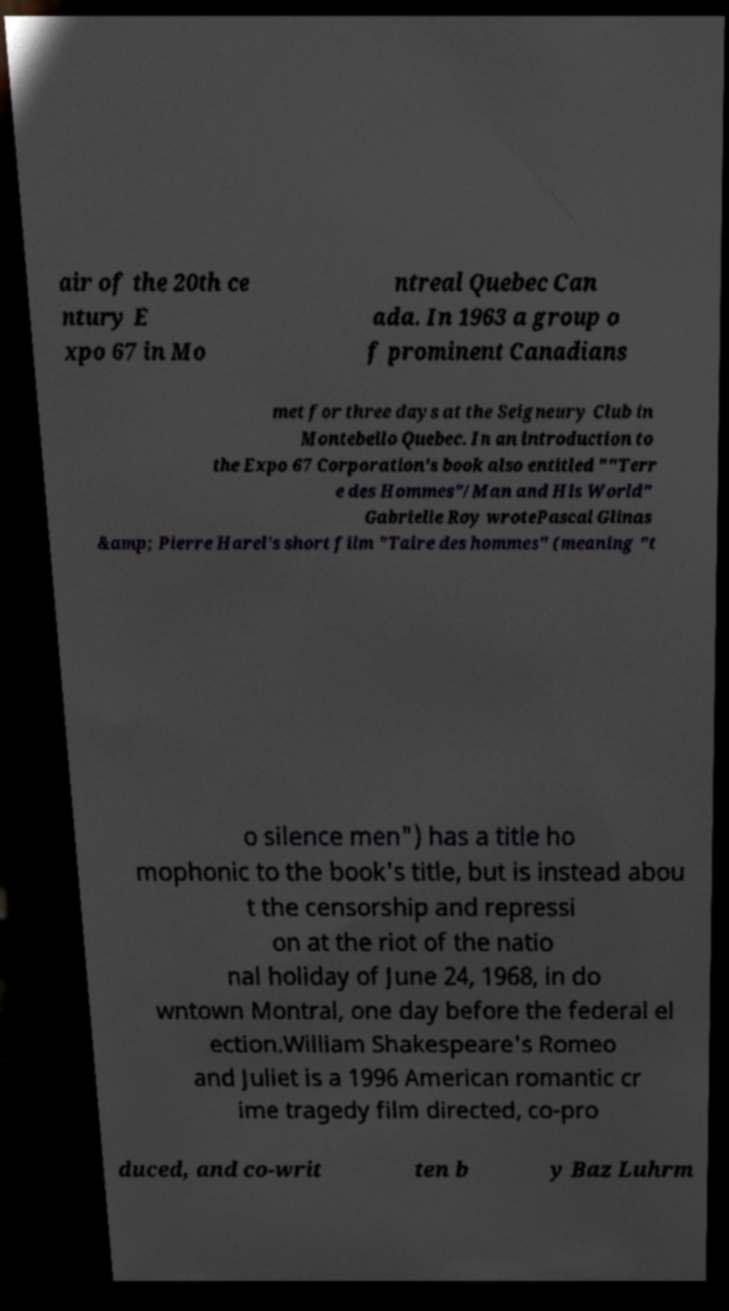Can you accurately transcribe the text from the provided image for me? air of the 20th ce ntury E xpo 67 in Mo ntreal Quebec Can ada. In 1963 a group o f prominent Canadians met for three days at the Seigneury Club in Montebello Quebec. In an introduction to the Expo 67 Corporation's book also entitled ""Terr e des Hommes"/Man and His World" Gabrielle Roy wrotePascal Glinas &amp; Pierre Harel's short film "Taire des hommes" (meaning "t o silence men") has a title ho mophonic to the book's title, but is instead abou t the censorship and repressi on at the riot of the natio nal holiday of June 24, 1968, in do wntown Montral, one day before the federal el ection.William Shakespeare's Romeo and Juliet is a 1996 American romantic cr ime tragedy film directed, co-pro duced, and co-writ ten b y Baz Luhrm 